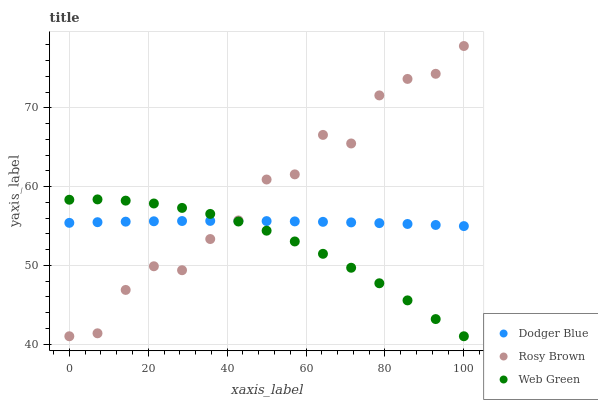Does Web Green have the minimum area under the curve?
Answer yes or no. Yes. Does Rosy Brown have the maximum area under the curve?
Answer yes or no. Yes. Does Dodger Blue have the minimum area under the curve?
Answer yes or no. No. Does Dodger Blue have the maximum area under the curve?
Answer yes or no. No. Is Dodger Blue the smoothest?
Answer yes or no. Yes. Is Rosy Brown the roughest?
Answer yes or no. Yes. Is Web Green the smoothest?
Answer yes or no. No. Is Web Green the roughest?
Answer yes or no. No. Does Rosy Brown have the lowest value?
Answer yes or no. Yes. Does Dodger Blue have the lowest value?
Answer yes or no. No. Does Rosy Brown have the highest value?
Answer yes or no. Yes. Does Web Green have the highest value?
Answer yes or no. No. Does Rosy Brown intersect Web Green?
Answer yes or no. Yes. Is Rosy Brown less than Web Green?
Answer yes or no. No. Is Rosy Brown greater than Web Green?
Answer yes or no. No. 